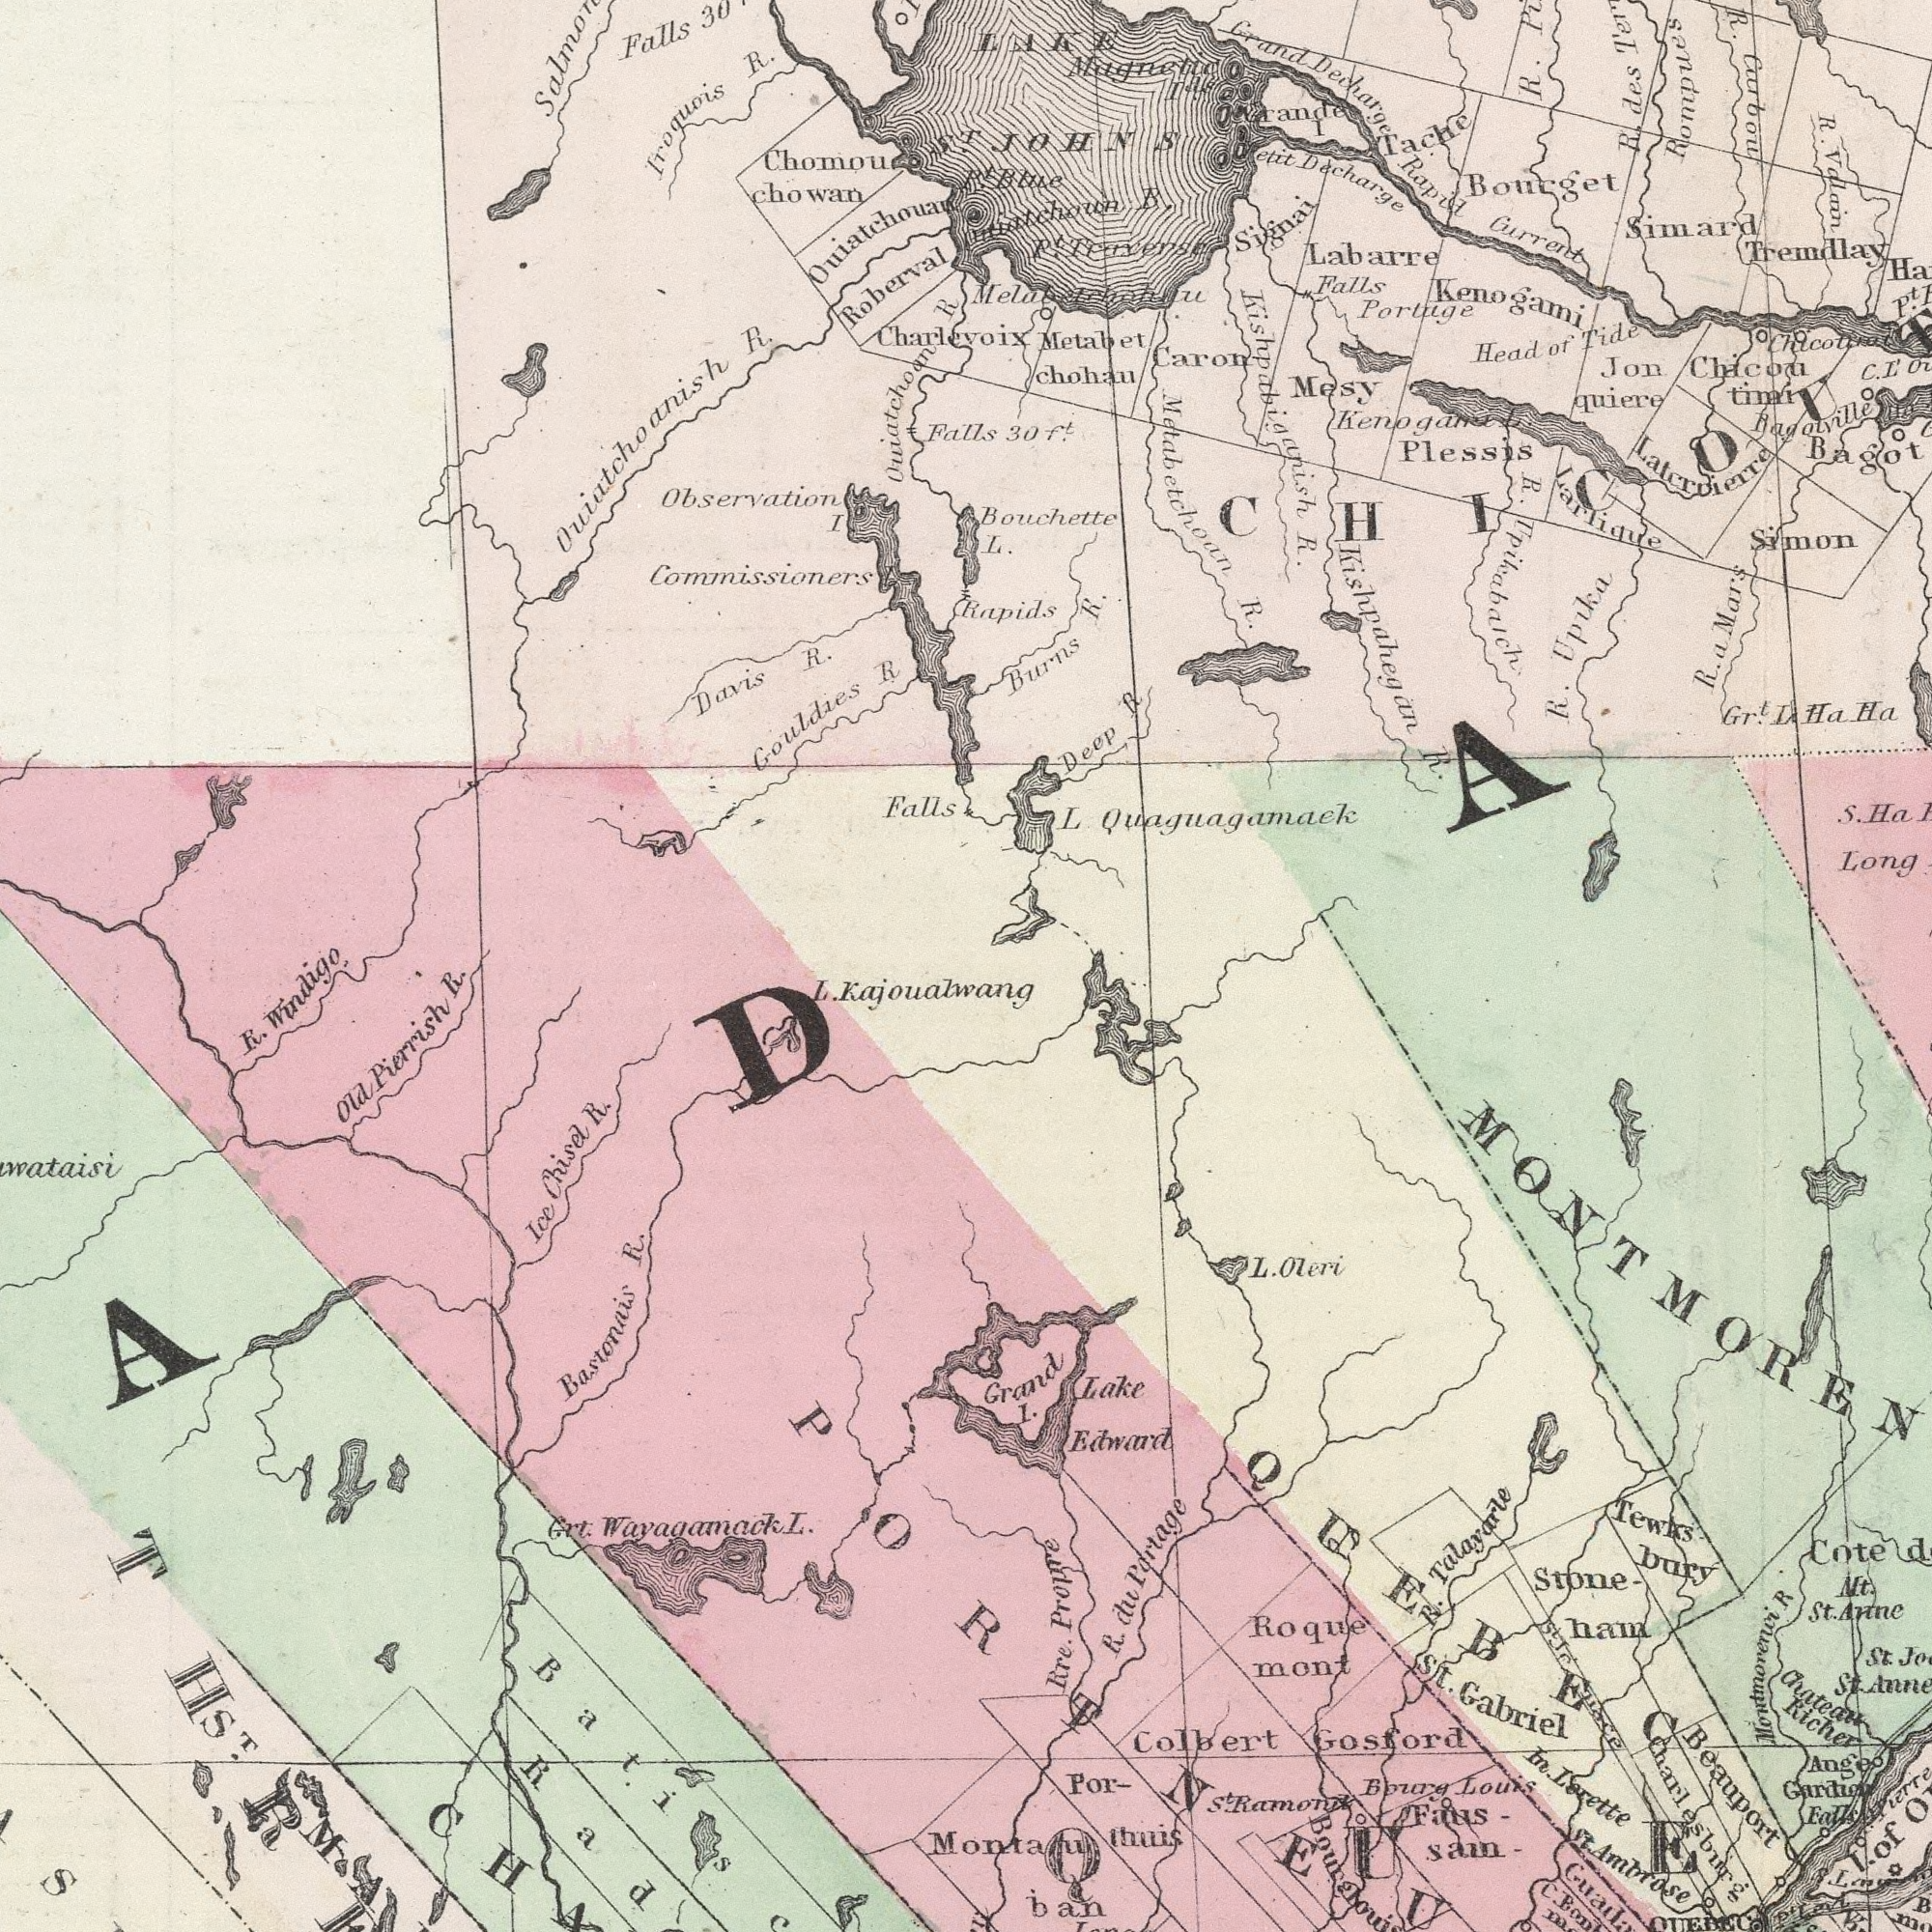What text is shown in the top-left quadrant? Observation I Falls Falls Ouiatchoanish R. Davis R. Iroquois R. Gouldies R Roberval Charlevoix Commissioners Ouiatchoan R Falls 30ft chowan Bouchette L. Burns Rapids ###atchoun P.t LAKE ST P.t Blue What text can you see in the bottom-right section? St. Gabriel Colbert Bourg Louis St. Ambrose Roque mont R In. Cote Beauport Tewks bury Gosford Rre. Faus sam Edward R. Talayarle Lake R. du Partage Chateau Richer Stone - ham St. S.t Ramond Por- thuis Nt. St. Anne Ealls St. Ange Guardien I. of Pierre ban C. Charlesbur g L. Oleri P. MONTMOREN PORTNEU QUEBEC What text can you see in the bottom-left section? Grt. Wayagamack L. Bastonais R. Ice Chisel R. Old Pierrish R. L. Kajoualwang R. Windle Propre Grand I. ST What text is visible in the upper-right corner? Plessis Simon R. Rapid Gurrent R. Upikabaich ###agotville R. des ###etit Decharge R. Valain R. Portage Grand Decharge Metabet chohau Simard Labarre Bourget R.a a Mars Kishpabiganish R. Mesy Jon quiere S. Ha Chicou timi Deep R R. Upika Signai Gr.t L Ha Ha R. Carbou Larlique Latcrrierre Tremdlay Kishpahegan R. Head of Tide Falls P.t Caron Rompues Bagot B. ###ande L Quaguagamaek Metabetchoan R. JOHNS Long Tache Kenogami Magnetic Ids I 